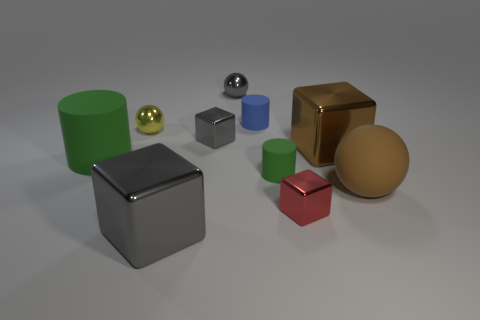Are there any other things that are the same shape as the small yellow object? Yes, the small yellow object is spherical, and there is another larger sphere in the back that is silver-colored. Additionally, other objects in the image share the characteristic of having a distinct, uniform geometric shape, like the cubes and cylinders present. 